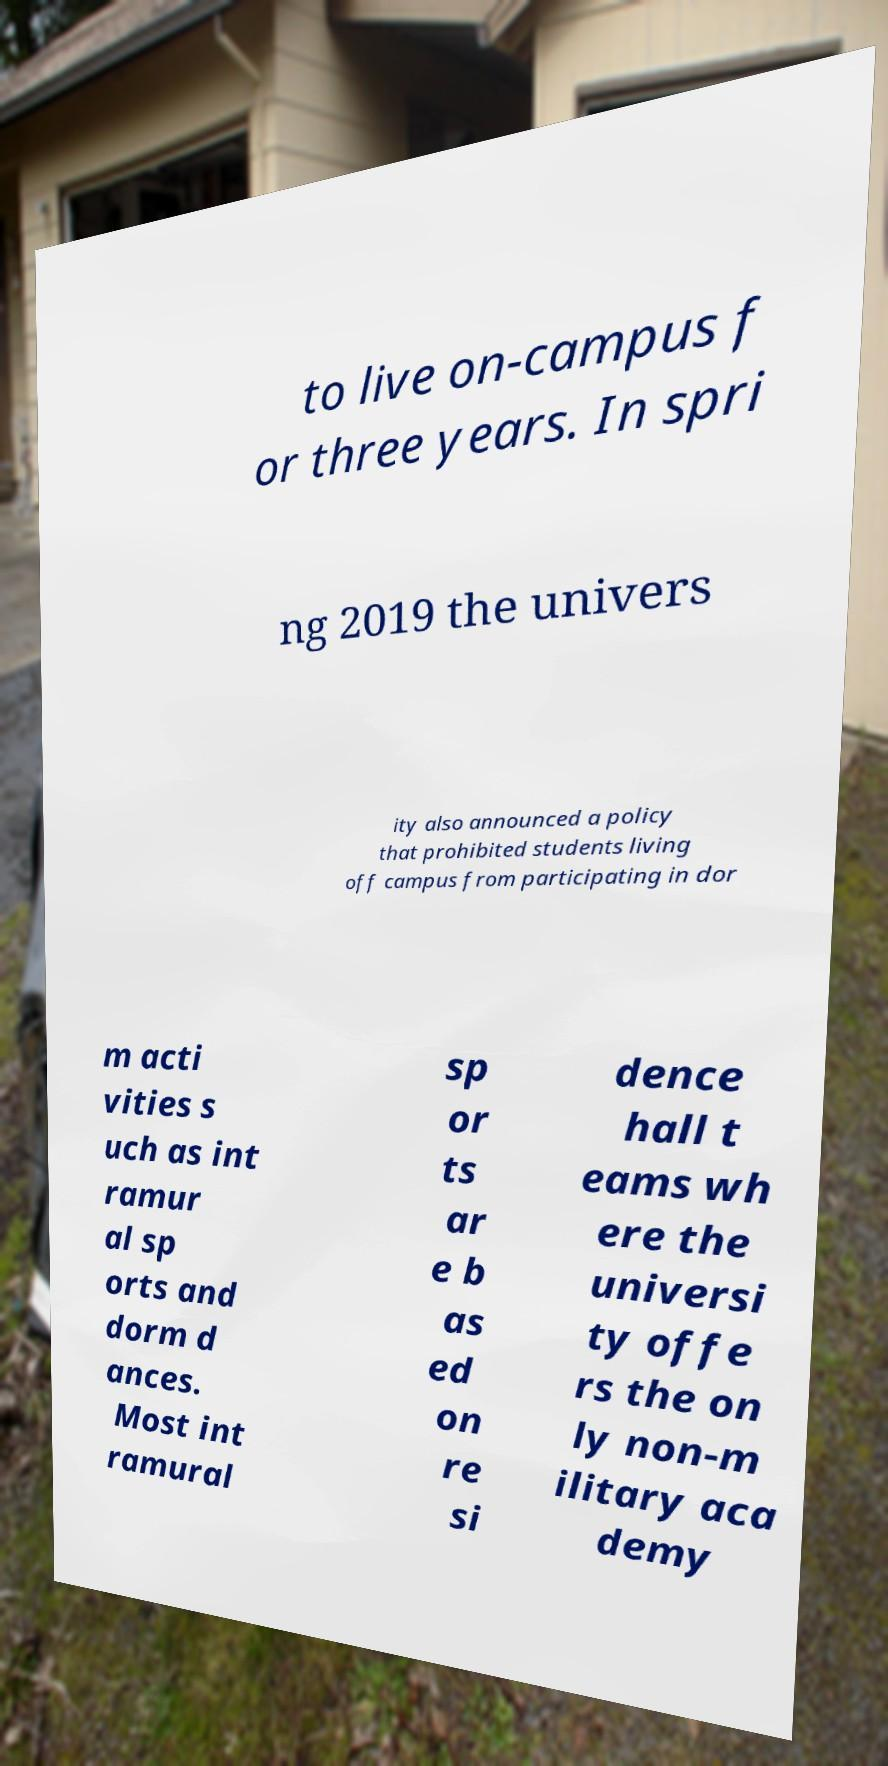Can you accurately transcribe the text from the provided image for me? to live on-campus f or three years. In spri ng 2019 the univers ity also announced a policy that prohibited students living off campus from participating in dor m acti vities s uch as int ramur al sp orts and dorm d ances. Most int ramural sp or ts ar e b as ed on re si dence hall t eams wh ere the universi ty offe rs the on ly non-m ilitary aca demy 